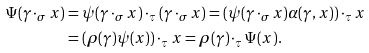<formula> <loc_0><loc_0><loc_500><loc_500>\Psi ( \gamma \cdot _ { \sigma } x ) & = \psi ( \gamma \cdot _ { \sigma } x ) \cdot _ { \tau } ( \gamma \cdot _ { \sigma } x ) = ( \psi ( \gamma \cdot _ { \sigma } x ) \alpha ( \gamma , x ) ) \cdot _ { \tau } x \\ & = ( \rho ( \gamma ) \psi ( x ) ) \cdot _ { \tau } x = \rho ( \gamma ) \cdot _ { \tau } \Psi ( x ) .</formula> 